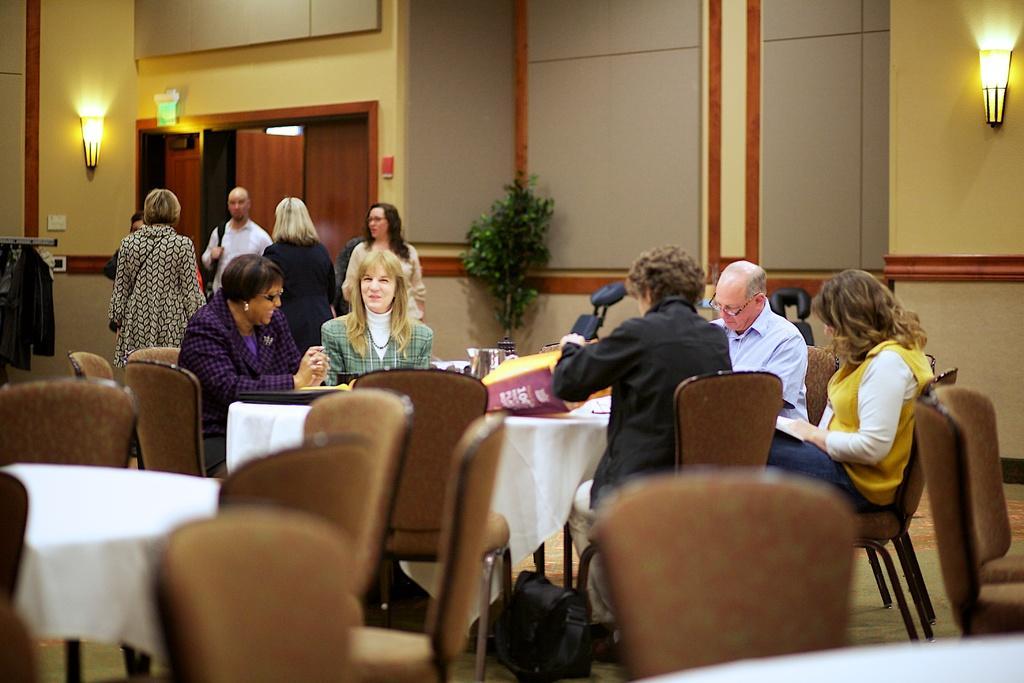Can you describe this image briefly? The picture looks like it is inside a building and there are many tables and chairs and the table is covered with a white colored cloth. Five members are sitting in front of the table. Two women are talking and smiling to each other. The man to the right is wearing a blue colored shirt and the woman is wearing yellow colored jacket. Here is door for entrance and a light on the wall. 